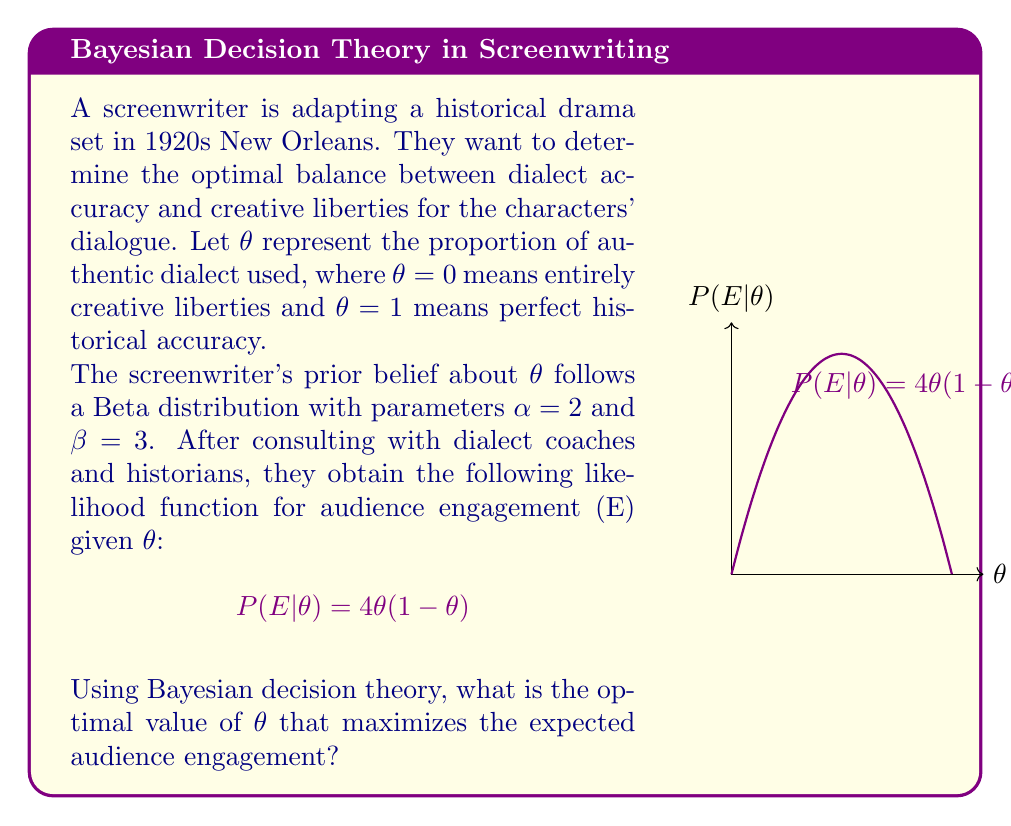What is the answer to this math problem? To solve this problem using Bayesian decision theory, we need to follow these steps:

1) First, we need to find the posterior distribution of $\theta$ given the data (audience engagement E).

2) The posterior distribution is proportional to the product of the prior and the likelihood:

   $$P(\theta|E) \propto P(\theta) \cdot P(E|\theta)$$

3) The prior is a Beta(2,3) distribution:
   
   $$P(\theta) \propto \theta^{1}(1-\theta)^{2}$$

4) Multiplying this by the likelihood:

   $$P(\theta|E) \propto \theta^{1}(1-\theta)^{2} \cdot 4\theta(1-\theta) = 4\theta^{2}(1-\theta)^{3}$$

5) This is proportional to a Beta(3,4) distribution.

6) In Bayesian decision theory, to maximize expected utility (in this case, audience engagement), we need to find the expected value of $\theta$ under the posterior distribution.

7) The expected value of a Beta(a,b) distribution is $\frac{a}{a+b}$.

8) Therefore, the optimal $\theta$ is:

   $$E[\theta|E] = \frac{3}{3+4} = \frac{3}{7} \approx 0.4286$$

This means the screenwriter should aim for about 42.86% authentic dialect and 57.14% creative liberties to maximize expected audience engagement.
Answer: $\frac{3}{7} \approx 0.4286$ 